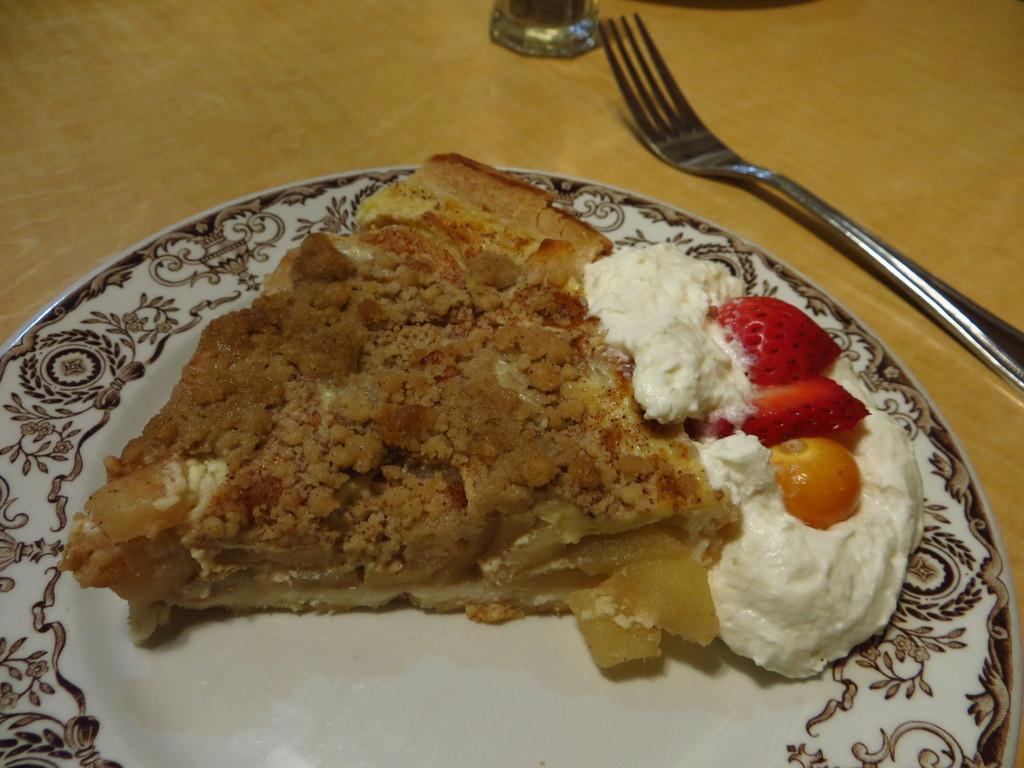Describe this image in one or two sentences. In the picture I can see some food item, ice cream and strawberries which are in white color plate and there is fork on wooden surface. 